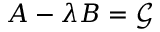<formula> <loc_0><loc_0><loc_500><loc_500>A - \lambda B = \mathcal { G }</formula> 